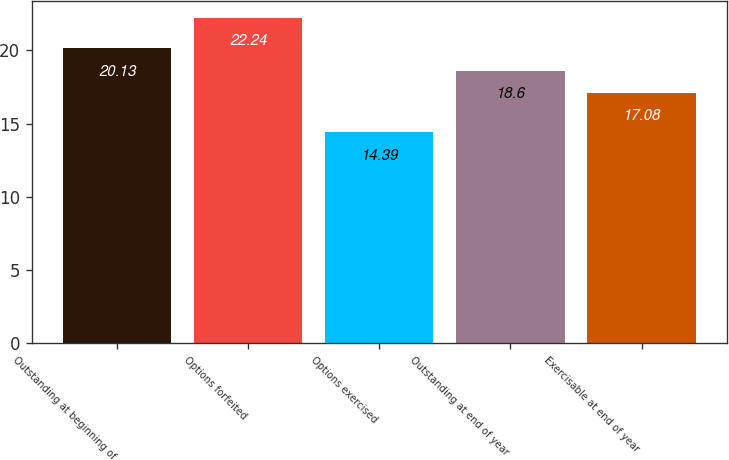Convert chart. <chart><loc_0><loc_0><loc_500><loc_500><bar_chart><fcel>Outstanding at beginning of<fcel>Options forfeited<fcel>Options exercised<fcel>Outstanding at end of year<fcel>Exercisable at end of year<nl><fcel>20.13<fcel>22.24<fcel>14.39<fcel>18.6<fcel>17.08<nl></chart> 